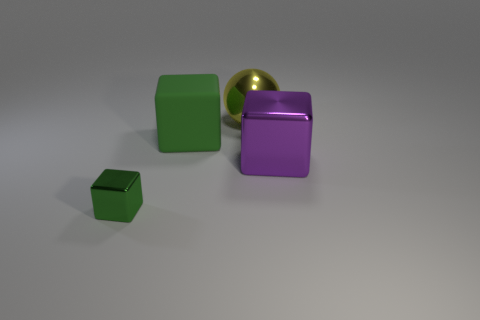Can you describe the colors and shapes visible in the image? In the image, there are four distinct items with varying colors and shapes. Starting from the left, there's a small green cube. Next to it is a large yellow, spherical ball with a glossy surface. Adjacent to the ball is a medium-sized green cube, and finally, on the far right, there's a large purple cube with a reflective surface. 